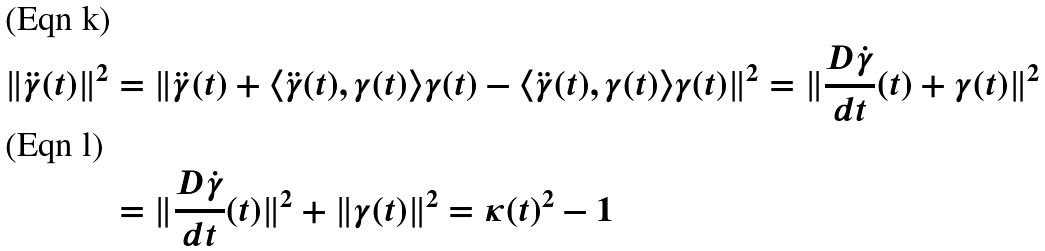Convert formula to latex. <formula><loc_0><loc_0><loc_500><loc_500>\| \ddot { \gamma } ( t ) \| ^ { 2 } & = \| \ddot { \gamma } ( t ) + \langle \ddot { \gamma } ( t ) , \gamma ( t ) \rangle \gamma ( t ) - \langle \ddot { \gamma } ( t ) , \gamma ( t ) \rangle \gamma ( t ) \| ^ { 2 } = \| \frac { D \dot { \gamma } } { d t } ( t ) + \gamma ( t ) \| ^ { 2 } \\ & = \| \frac { D \dot { \gamma } } { d t } ( t ) \| ^ { 2 } + \| \gamma ( t ) \| ^ { 2 } = \kappa ( t ) ^ { 2 } - 1</formula> 